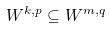<formula> <loc_0><loc_0><loc_500><loc_500>W ^ { k , p } \subseteq W ^ { m , q }</formula> 